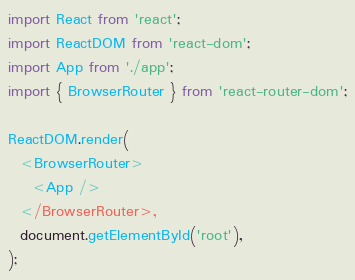<code> <loc_0><loc_0><loc_500><loc_500><_JavaScript_>import React from 'react';
import ReactDOM from 'react-dom';
import App from './app';
import { BrowserRouter } from 'react-router-dom';

ReactDOM.render(
  <BrowserRouter>
    <App />
  </BrowserRouter>,
  document.getElementById('root'),
);
</code> 